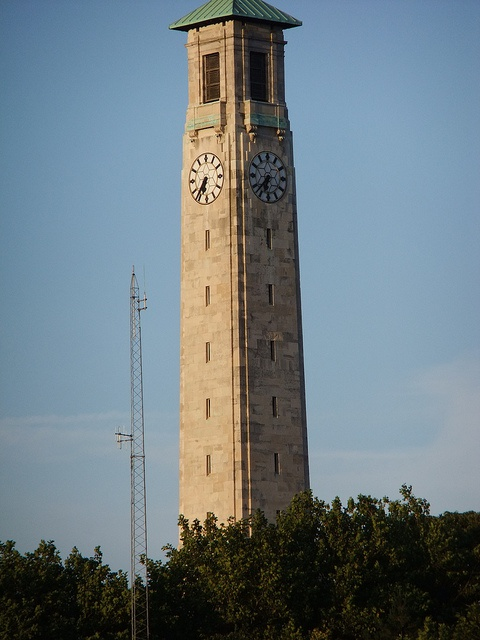Describe the objects in this image and their specific colors. I can see clock in gray, tan, beige, and black tones and clock in gray, black, and darkblue tones in this image. 